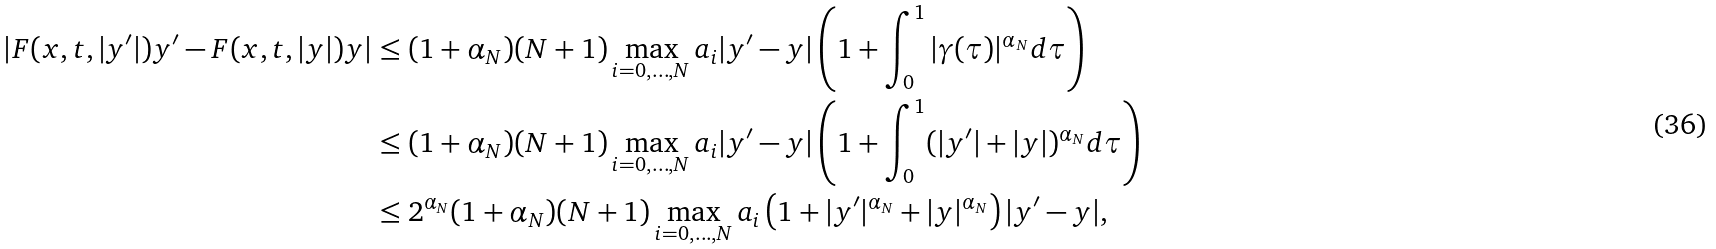<formula> <loc_0><loc_0><loc_500><loc_500>| F ( x , t , | y ^ { \prime } | ) y ^ { \prime } - F ( x , t , | y | ) y | & \leq ( 1 + \alpha _ { N } ) ( N + 1 ) \max _ { i = 0 , \dots , N } a _ { i } | y ^ { \prime } - y | \left ( 1 + \int _ { 0 } ^ { 1 } | \gamma ( \tau ) | ^ { \alpha _ { N } } d \tau \right ) \\ & \leq ( 1 + \alpha _ { N } ) ( N + 1 ) \max _ { i = 0 , \dots , N } a _ { i } | y ^ { \prime } - y | \left ( 1 + \int _ { 0 } ^ { 1 } ( | y ^ { \prime } | + | y | ) ^ { \alpha _ { N } } d \tau \right ) \\ & \leq 2 ^ { \alpha _ { N } } ( 1 + \alpha _ { N } ) ( N + 1 ) \max _ { i = 0 , \dots , N } a _ { i } \left ( 1 + | y ^ { \prime } | ^ { \alpha _ { N } } + | y | ^ { \alpha _ { N } } \right ) | y ^ { \prime } - y | ,</formula> 